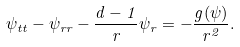<formula> <loc_0><loc_0><loc_500><loc_500>\psi _ { t t } - \psi _ { r r } - \frac { d - 1 } { r } \psi _ { r } = - \frac { g ( \psi ) } { r ^ { 2 } } .</formula> 